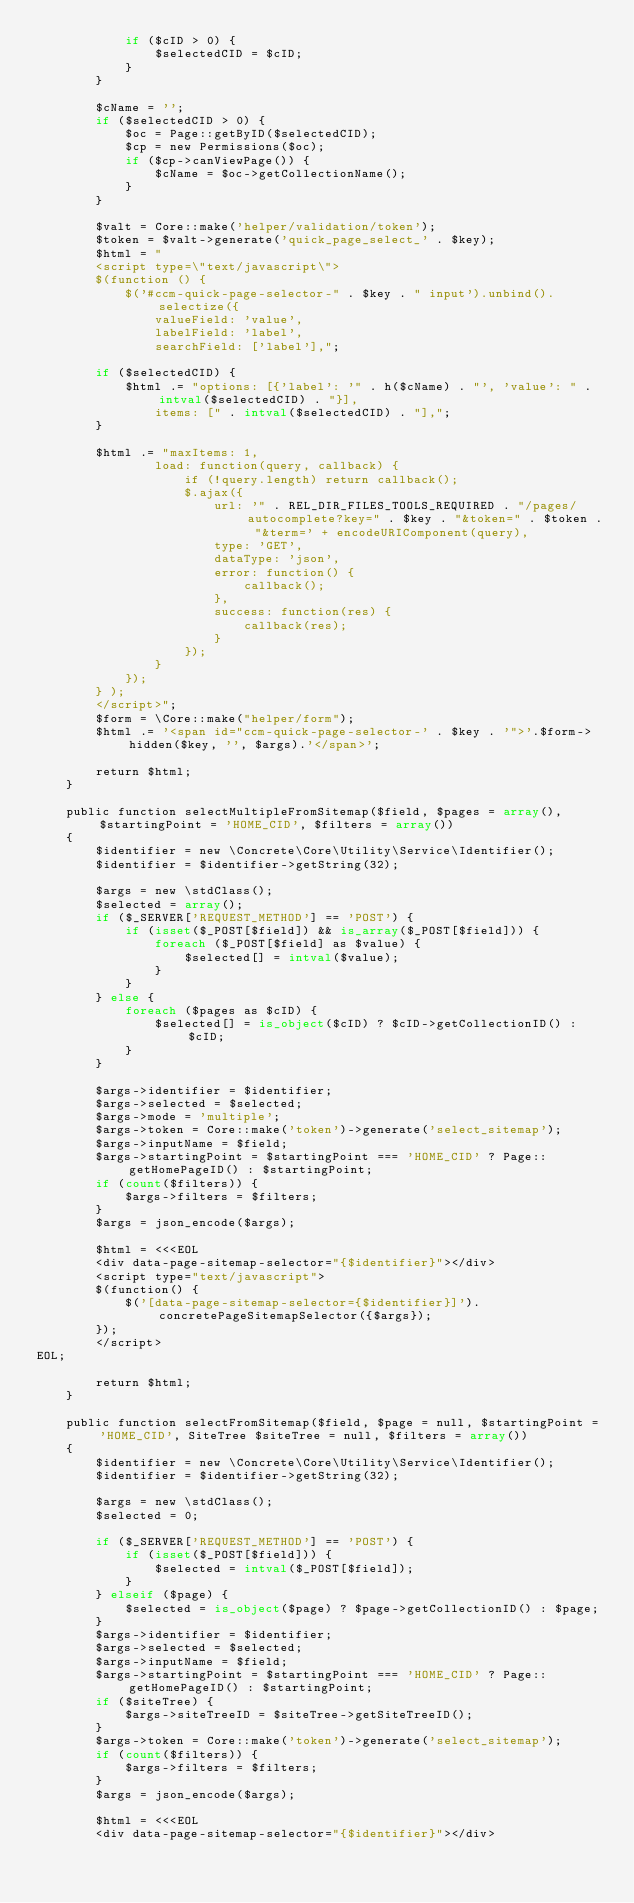<code> <loc_0><loc_0><loc_500><loc_500><_PHP_>            if ($cID > 0) {
                $selectedCID = $cID;
            }
        }

        $cName = '';
        if ($selectedCID > 0) {
            $oc = Page::getByID($selectedCID);
            $cp = new Permissions($oc);
            if ($cp->canViewPage()) {
                $cName = $oc->getCollectionName();
            }
        }

        $valt = Core::make('helper/validation/token');
        $token = $valt->generate('quick_page_select_' . $key);
        $html = "
		<script type=\"text/javascript\">
		$(function () {
			$('#ccm-quick-page-selector-" . $key . " input').unbind().selectize({
                valueField: 'value',
                labelField: 'label',
                searchField: ['label'],";

        if ($selectedCID) {
            $html .= "options: [{'label': '" . h($cName) . "', 'value': " . intval($selectedCID) . "}],
				items: [" . intval($selectedCID) . "],";
        }

        $html .= "maxItems: 1,
                load: function(query, callback) {
                    if (!query.length) return callback();
                    $.ajax({
                        url: '" . REL_DIR_FILES_TOOLS_REQUIRED . "/pages/autocomplete?key=" . $key . "&token=" . $token . "&term=' + encodeURIComponent(query),
                        type: 'GET',
						dataType: 'json',
                        error: function() {
                            callback();
                        },
                        success: function(res) {
                            callback(res);
                        }
                    });
                }
		    });
		} );
		</script>";
        $form = \Core::make("helper/form");
        $html .= '<span id="ccm-quick-page-selector-' . $key . '">'.$form->hidden($key, '', $args).'</span>';

        return $html;
    }

    public function selectMultipleFromSitemap($field, $pages = array(), $startingPoint = 'HOME_CID', $filters = array())
    {
        $identifier = new \Concrete\Core\Utility\Service\Identifier();
        $identifier = $identifier->getString(32);

        $args = new \stdClass();
        $selected = array();
        if ($_SERVER['REQUEST_METHOD'] == 'POST') {
            if (isset($_POST[$field]) && is_array($_POST[$field])) {
                foreach ($_POST[$field] as $value) {
                    $selected[] = intval($value);
                }
            }
        } else {
            foreach ($pages as $cID) {
                $selected[] = is_object($cID) ? $cID->getCollectionID() : $cID;
            }
        }

        $args->identifier = $identifier;
        $args->selected = $selected;
        $args->mode = 'multiple';
        $args->token = Core::make('token')->generate('select_sitemap');
        $args->inputName = $field;
        $args->startingPoint = $startingPoint === 'HOME_CID' ? Page::getHomePageID() : $startingPoint;
        if (count($filters)) {
            $args->filters = $filters;
        }
        $args = json_encode($args);

        $html = <<<EOL
        <div data-page-sitemap-selector="{$identifier}"></div>
        <script type="text/javascript">
        $(function() {
            $('[data-page-sitemap-selector={$identifier}]').concretePageSitemapSelector({$args});
        });
        </script>
EOL;

        return $html;
    }

    public function selectFromSitemap($field, $page = null, $startingPoint = 'HOME_CID', SiteTree $siteTree = null, $filters = array())
    {
        $identifier = new \Concrete\Core\Utility\Service\Identifier();
        $identifier = $identifier->getString(32);

        $args = new \stdClass();
        $selected = 0;

        if ($_SERVER['REQUEST_METHOD'] == 'POST') {
            if (isset($_POST[$field])) {
                $selected = intval($_POST[$field]);
            }
        } elseif ($page) {
            $selected = is_object($page) ? $page->getCollectionID() : $page;
        }
        $args->identifier = $identifier;
        $args->selected = $selected;
        $args->inputName = $field;
        $args->startingPoint = $startingPoint === 'HOME_CID' ? Page::getHomePageID() : $startingPoint;
        if ($siteTree) {
            $args->siteTreeID = $siteTree->getSiteTreeID();
        }
        $args->token = Core::make('token')->generate('select_sitemap');
        if (count($filters)) {
            $args->filters = $filters;
        }
        $args = json_encode($args);

        $html = <<<EOL
        <div data-page-sitemap-selector="{$identifier}"></div></code> 